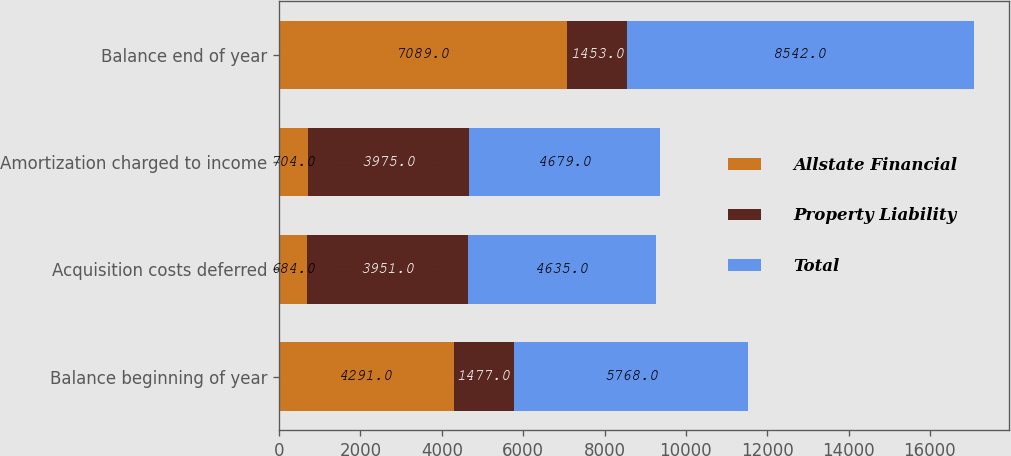Convert chart. <chart><loc_0><loc_0><loc_500><loc_500><stacked_bar_chart><ecel><fcel>Balance beginning of year<fcel>Acquisition costs deferred<fcel>Amortization charged to income<fcel>Balance end of year<nl><fcel>Allstate Financial<fcel>4291<fcel>684<fcel>704<fcel>7089<nl><fcel>Property Liability<fcel>1477<fcel>3951<fcel>3975<fcel>1453<nl><fcel>Total<fcel>5768<fcel>4635<fcel>4679<fcel>8542<nl></chart> 